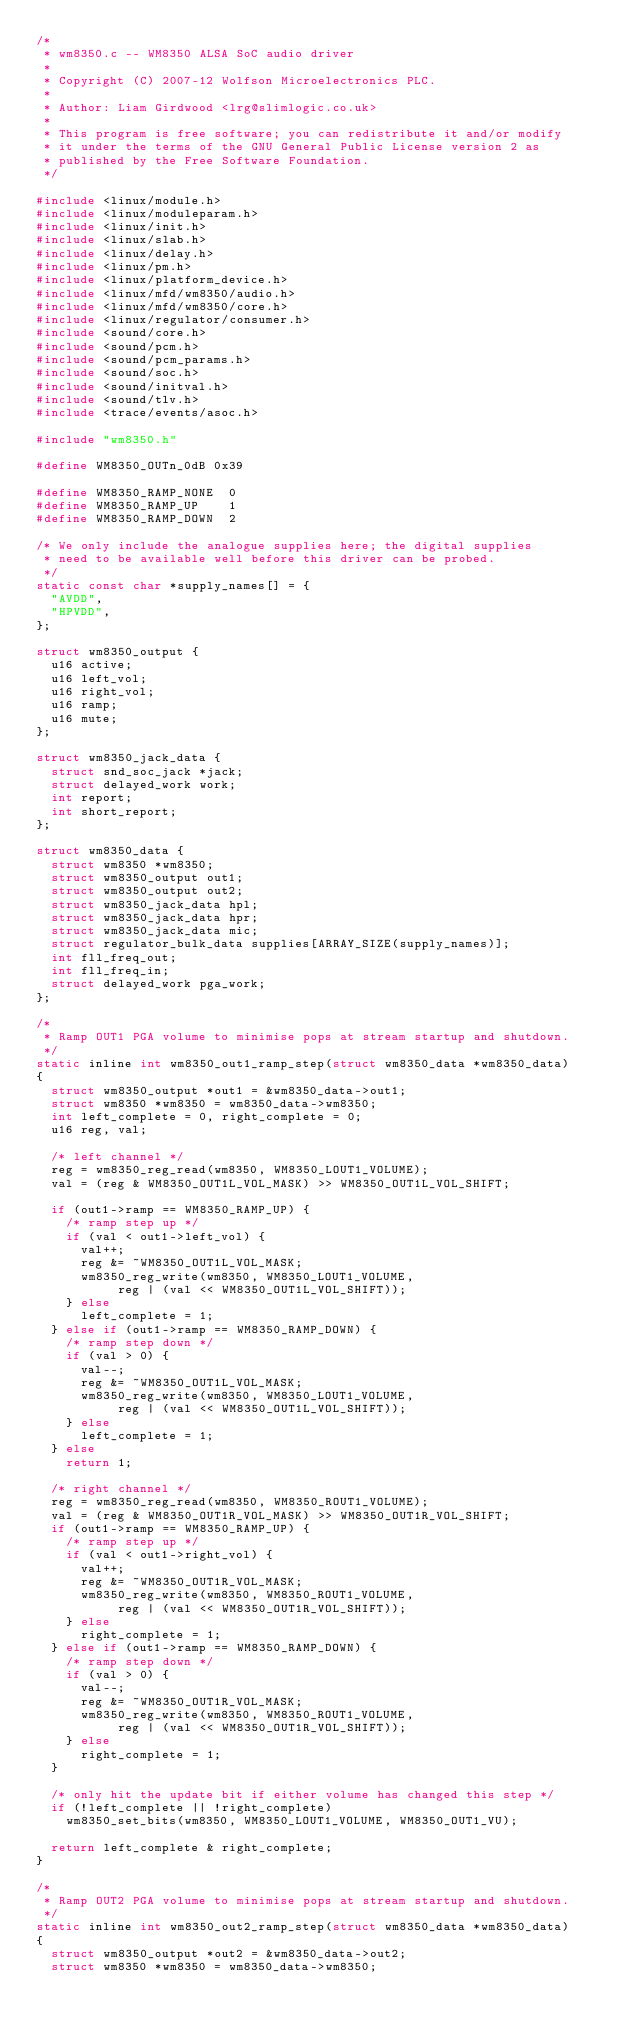Convert code to text. <code><loc_0><loc_0><loc_500><loc_500><_C_>/*
 * wm8350.c -- WM8350 ALSA SoC audio driver
 *
 * Copyright (C) 2007-12 Wolfson Microelectronics PLC.
 *
 * Author: Liam Girdwood <lrg@slimlogic.co.uk>
 *
 * This program is free software; you can redistribute it and/or modify
 * it under the terms of the GNU General Public License version 2 as
 * published by the Free Software Foundation.
 */

#include <linux/module.h>
#include <linux/moduleparam.h>
#include <linux/init.h>
#include <linux/slab.h>
#include <linux/delay.h>
#include <linux/pm.h>
#include <linux/platform_device.h>
#include <linux/mfd/wm8350/audio.h>
#include <linux/mfd/wm8350/core.h>
#include <linux/regulator/consumer.h>
#include <sound/core.h>
#include <sound/pcm.h>
#include <sound/pcm_params.h>
#include <sound/soc.h>
#include <sound/initval.h>
#include <sound/tlv.h>
#include <trace/events/asoc.h>

#include "wm8350.h"

#define WM8350_OUTn_0dB 0x39

#define WM8350_RAMP_NONE	0
#define WM8350_RAMP_UP		1
#define WM8350_RAMP_DOWN	2

/* We only include the analogue supplies here; the digital supplies
 * need to be available well before this driver can be probed.
 */
static const char *supply_names[] = {
	"AVDD",
	"HPVDD",
};

struct wm8350_output {
	u16 active;
	u16 left_vol;
	u16 right_vol;
	u16 ramp;
	u16 mute;
};

struct wm8350_jack_data {
	struct snd_soc_jack *jack;
	struct delayed_work work;
	int report;
	int short_report;
};

struct wm8350_data {
	struct wm8350 *wm8350;
	struct wm8350_output out1;
	struct wm8350_output out2;
	struct wm8350_jack_data hpl;
	struct wm8350_jack_data hpr;
	struct wm8350_jack_data mic;
	struct regulator_bulk_data supplies[ARRAY_SIZE(supply_names)];
	int fll_freq_out;
	int fll_freq_in;
	struct delayed_work pga_work;
};

/*
 * Ramp OUT1 PGA volume to minimise pops at stream startup and shutdown.
 */
static inline int wm8350_out1_ramp_step(struct wm8350_data *wm8350_data)
{
	struct wm8350_output *out1 = &wm8350_data->out1;
	struct wm8350 *wm8350 = wm8350_data->wm8350;
	int left_complete = 0, right_complete = 0;
	u16 reg, val;

	/* left channel */
	reg = wm8350_reg_read(wm8350, WM8350_LOUT1_VOLUME);
	val = (reg & WM8350_OUT1L_VOL_MASK) >> WM8350_OUT1L_VOL_SHIFT;

	if (out1->ramp == WM8350_RAMP_UP) {
		/* ramp step up */
		if (val < out1->left_vol) {
			val++;
			reg &= ~WM8350_OUT1L_VOL_MASK;
			wm8350_reg_write(wm8350, WM8350_LOUT1_VOLUME,
					 reg | (val << WM8350_OUT1L_VOL_SHIFT));
		} else
			left_complete = 1;
	} else if (out1->ramp == WM8350_RAMP_DOWN) {
		/* ramp step down */
		if (val > 0) {
			val--;
			reg &= ~WM8350_OUT1L_VOL_MASK;
			wm8350_reg_write(wm8350, WM8350_LOUT1_VOLUME,
					 reg | (val << WM8350_OUT1L_VOL_SHIFT));
		} else
			left_complete = 1;
	} else
		return 1;

	/* right channel */
	reg = wm8350_reg_read(wm8350, WM8350_ROUT1_VOLUME);
	val = (reg & WM8350_OUT1R_VOL_MASK) >> WM8350_OUT1R_VOL_SHIFT;
	if (out1->ramp == WM8350_RAMP_UP) {
		/* ramp step up */
		if (val < out1->right_vol) {
			val++;
			reg &= ~WM8350_OUT1R_VOL_MASK;
			wm8350_reg_write(wm8350, WM8350_ROUT1_VOLUME,
					 reg | (val << WM8350_OUT1R_VOL_SHIFT));
		} else
			right_complete = 1;
	} else if (out1->ramp == WM8350_RAMP_DOWN) {
		/* ramp step down */
		if (val > 0) {
			val--;
			reg &= ~WM8350_OUT1R_VOL_MASK;
			wm8350_reg_write(wm8350, WM8350_ROUT1_VOLUME,
					 reg | (val << WM8350_OUT1R_VOL_SHIFT));
		} else
			right_complete = 1;
	}

	/* only hit the update bit if either volume has changed this step */
	if (!left_complete || !right_complete)
		wm8350_set_bits(wm8350, WM8350_LOUT1_VOLUME, WM8350_OUT1_VU);

	return left_complete & right_complete;
}

/*
 * Ramp OUT2 PGA volume to minimise pops at stream startup and shutdown.
 */
static inline int wm8350_out2_ramp_step(struct wm8350_data *wm8350_data)
{
	struct wm8350_output *out2 = &wm8350_data->out2;
	struct wm8350 *wm8350 = wm8350_data->wm8350;</code> 